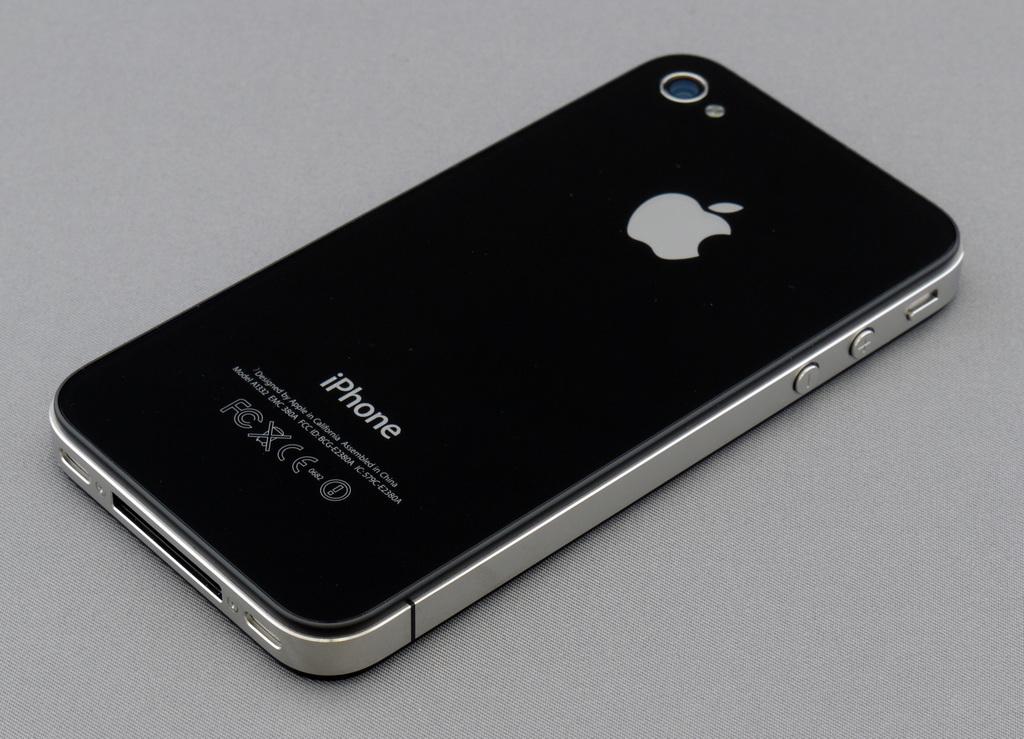What kind of phone is this?
Offer a terse response. Iphone. What is the apple product seen here?
Give a very brief answer. Iphone. 